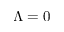<formula> <loc_0><loc_0><loc_500><loc_500>\Lambda = 0</formula> 